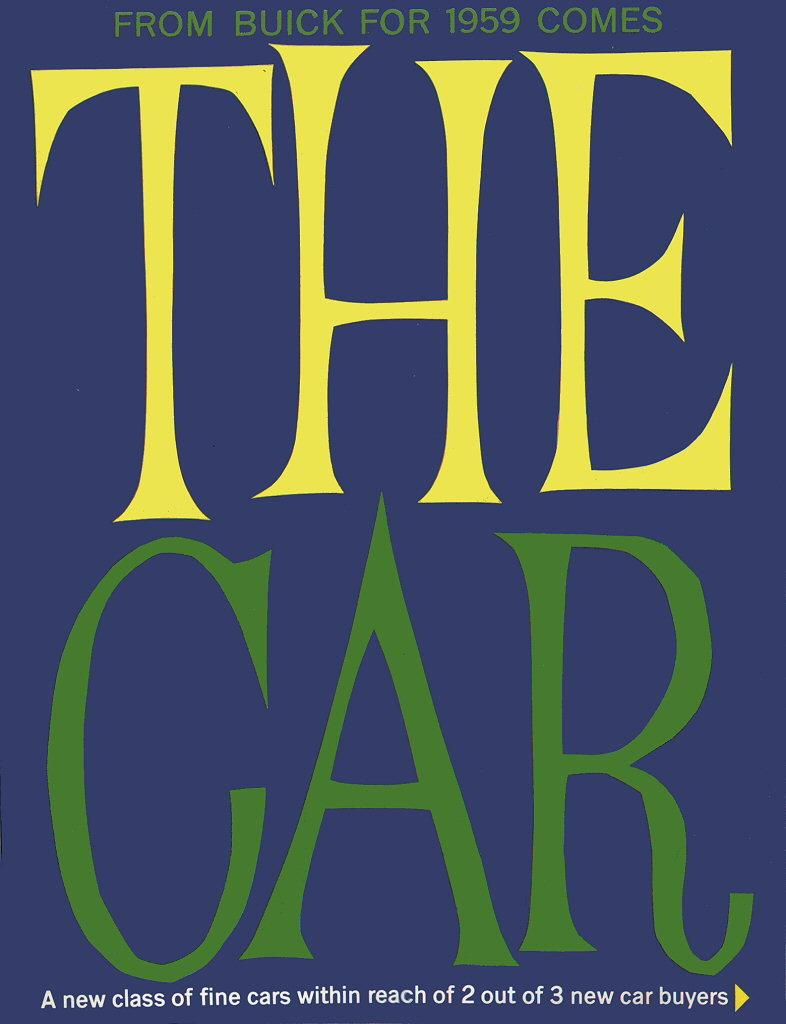<image>
Write a terse but informative summary of the picture. A card from Buick for 1959 comes the car. 